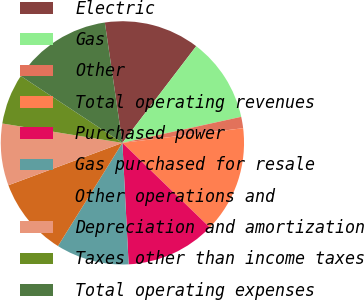Convert chart. <chart><loc_0><loc_0><loc_500><loc_500><pie_chart><fcel>Electric<fcel>Gas<fcel>Other<fcel>Total operating revenues<fcel>Purchased power<fcel>Gas purchased for resale<fcel>Other operations and<fcel>Depreciation and amortization<fcel>Taxes other than income taxes<fcel>Total operating expenses<nl><fcel>12.68%<fcel>11.19%<fcel>1.51%<fcel>14.17%<fcel>11.94%<fcel>9.7%<fcel>10.45%<fcel>8.21%<fcel>6.72%<fcel>13.43%<nl></chart> 